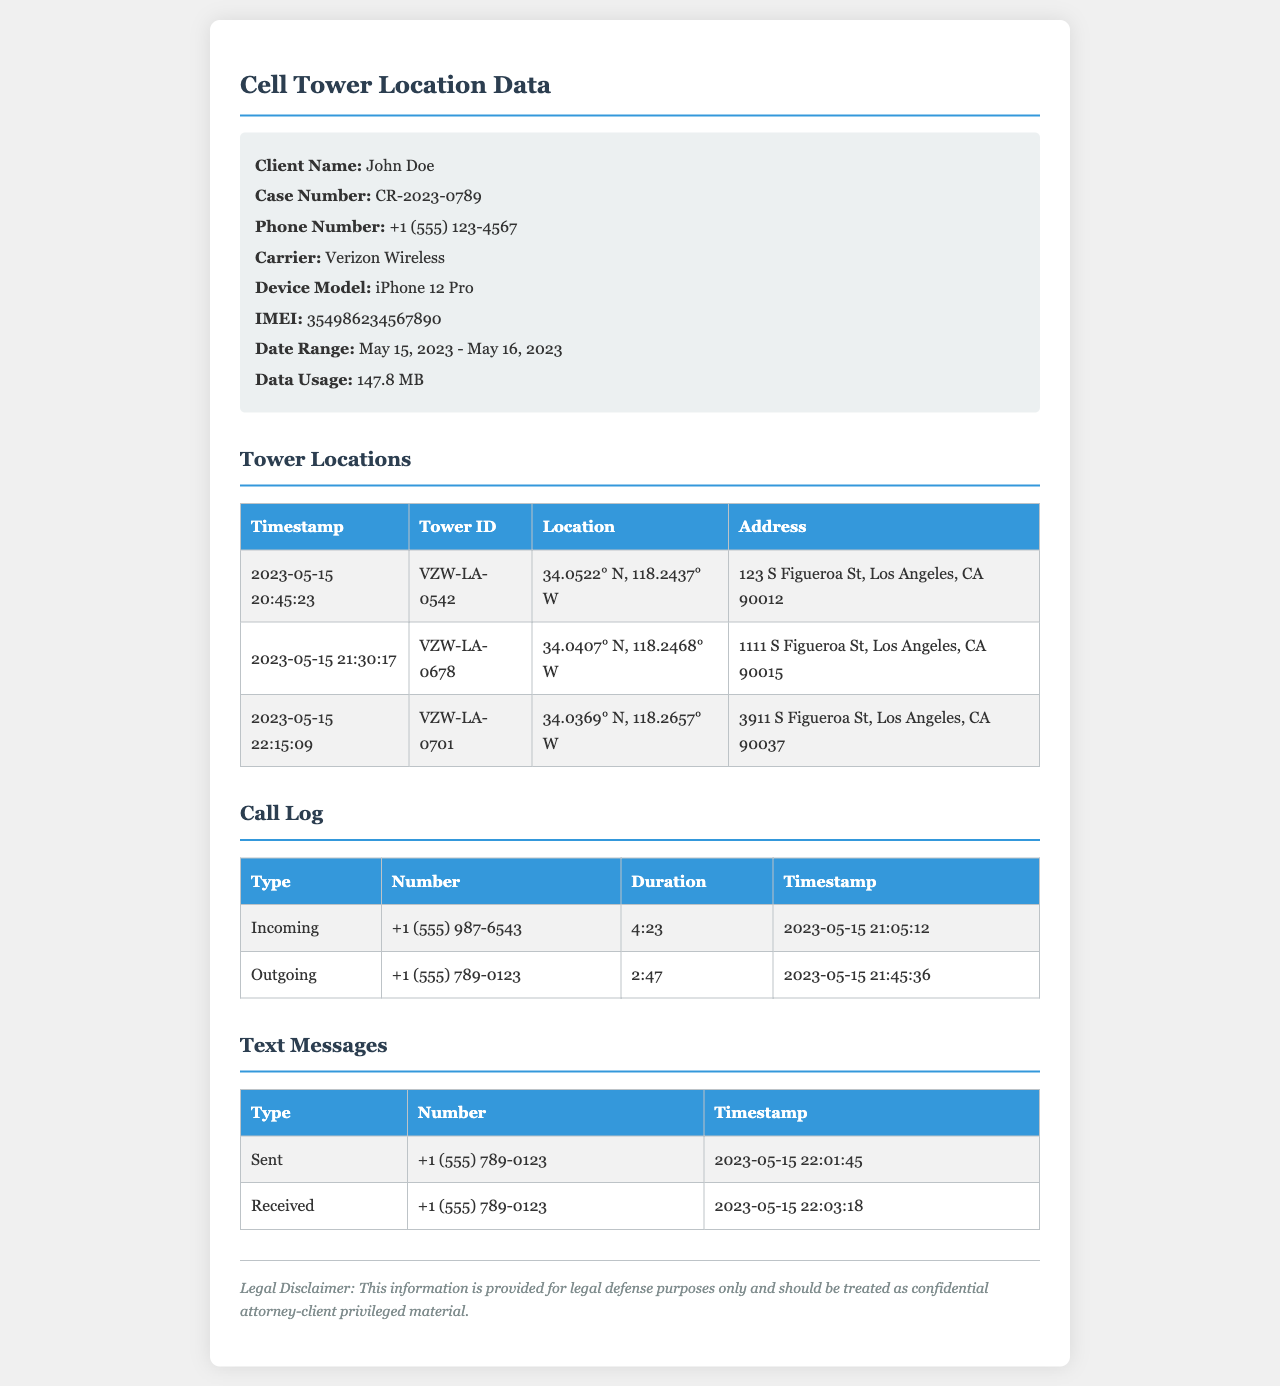what is the client's name? The client's name is specified in the client information section of the document.
Answer: John Doe what is the case number? The case number is provided in the client information section of the document.
Answer: CR-2023-0789 what is the phone number? The phone number is listed under the client information section of the document.
Answer: +1 (555) 123-4567 how many towers were contacted on May 15, 2023? The document contains details of the cell towers accessed on May 15, 2023, noted in the tower locations section.
Answer: 3 what was the timestamp of the incoming call? The timestamp for the incoming call is listed in the call log section of the document.
Answer: 2023-05-15 21:05:12 where was the client located at 20:45:23? The location is specified in the tower locations section under the timestamp of 20:45:23.
Answer: 123 S Figueroa St, Los Angeles, CA 90012 how long was the outgoing call made? The duration of the outgoing call appears in the call log section of the document.
Answer: 2:47 what type of device did the client use? The type of device is mentioned in the client information section of the document.
Answer: iPhone 12 Pro what is the total data usage recorded? The total data usage is provided in the client information section under data usage.
Answer: 147.8 MB 